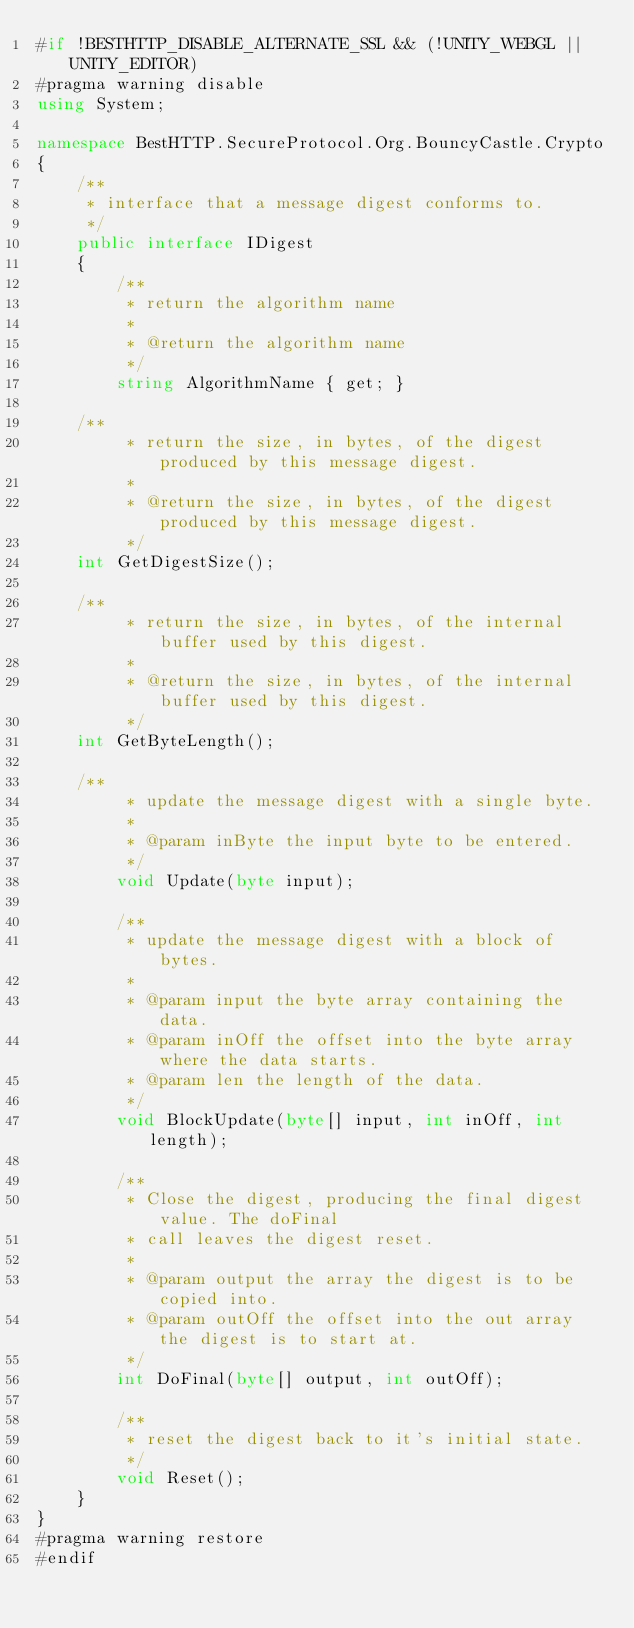Convert code to text. <code><loc_0><loc_0><loc_500><loc_500><_C#_>#if !BESTHTTP_DISABLE_ALTERNATE_SSL && (!UNITY_WEBGL || UNITY_EDITOR)
#pragma warning disable
using System;

namespace BestHTTP.SecureProtocol.Org.BouncyCastle.Crypto
{
    /**
     * interface that a message digest conforms to.
     */
    public interface IDigest
    {
        /**
         * return the algorithm name
         *
         * @return the algorithm name
         */
        string AlgorithmName { get; }

		/**
         * return the size, in bytes, of the digest produced by this message digest.
         *
         * @return the size, in bytes, of the digest produced by this message digest.
         */
		int GetDigestSize();

		/**
         * return the size, in bytes, of the internal buffer used by this digest.
         *
         * @return the size, in bytes, of the internal buffer used by this digest.
         */
		int GetByteLength();

		/**
         * update the message digest with a single byte.
         *
         * @param inByte the input byte to be entered.
         */
        void Update(byte input);

        /**
         * update the message digest with a block of bytes.
         *
         * @param input the byte array containing the data.
         * @param inOff the offset into the byte array where the data starts.
         * @param len the length of the data.
         */
        void BlockUpdate(byte[] input, int inOff, int length);

        /**
         * Close the digest, producing the final digest value. The doFinal
         * call leaves the digest reset.
         *
         * @param output the array the digest is to be copied into.
         * @param outOff the offset into the out array the digest is to start at.
         */
        int DoFinal(byte[] output, int outOff);

        /**
         * reset the digest back to it's initial state.
         */
        void Reset();
    }
}
#pragma warning restore
#endif
</code> 